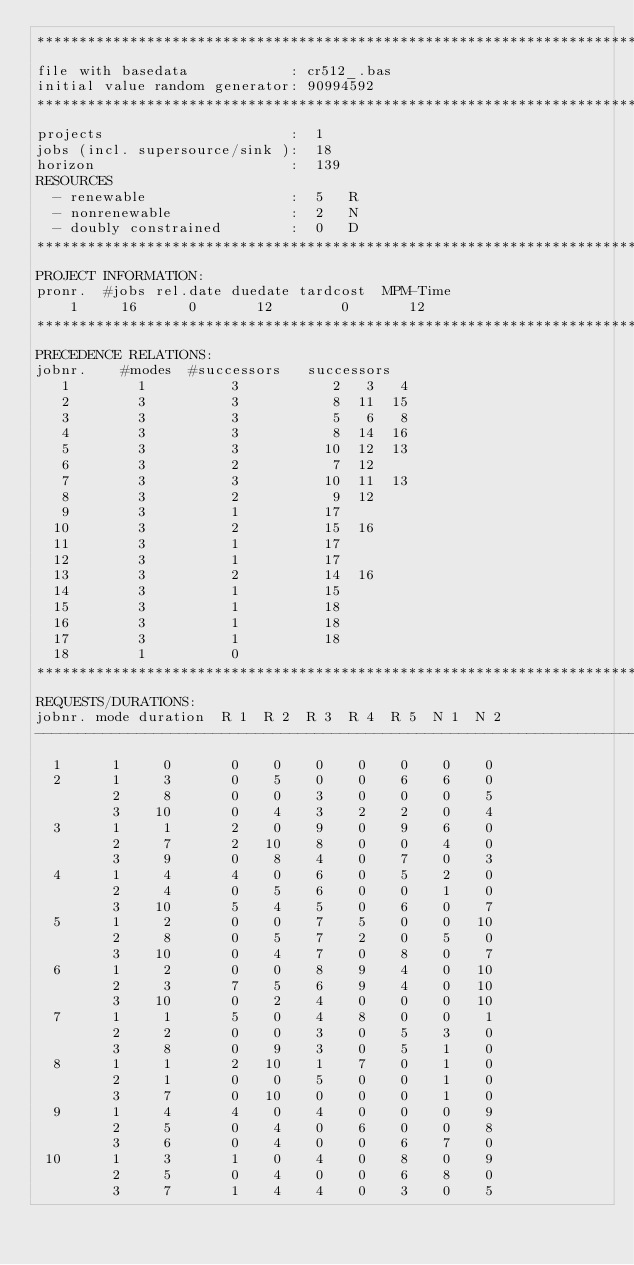Convert code to text. <code><loc_0><loc_0><loc_500><loc_500><_ObjectiveC_>************************************************************************
file with basedata            : cr512_.bas
initial value random generator: 90994592
************************************************************************
projects                      :  1
jobs (incl. supersource/sink ):  18
horizon                       :  139
RESOURCES
  - renewable                 :  5   R
  - nonrenewable              :  2   N
  - doubly constrained        :  0   D
************************************************************************
PROJECT INFORMATION:
pronr.  #jobs rel.date duedate tardcost  MPM-Time
    1     16      0       12        0       12
************************************************************************
PRECEDENCE RELATIONS:
jobnr.    #modes  #successors   successors
   1        1          3           2   3   4
   2        3          3           8  11  15
   3        3          3           5   6   8
   4        3          3           8  14  16
   5        3          3          10  12  13
   6        3          2           7  12
   7        3          3          10  11  13
   8        3          2           9  12
   9        3          1          17
  10        3          2          15  16
  11        3          1          17
  12        3          1          17
  13        3          2          14  16
  14        3          1          15
  15        3          1          18
  16        3          1          18
  17        3          1          18
  18        1          0        
************************************************************************
REQUESTS/DURATIONS:
jobnr. mode duration  R 1  R 2  R 3  R 4  R 5  N 1  N 2
------------------------------------------------------------------------
  1      1     0       0    0    0    0    0    0    0
  2      1     3       0    5    0    0    6    6    0
         2     8       0    0    3    0    0    0    5
         3    10       0    4    3    2    2    0    4
  3      1     1       2    0    9    0    9    6    0
         2     7       2   10    8    0    0    4    0
         3     9       0    8    4    0    7    0    3
  4      1     4       4    0    6    0    5    2    0
         2     4       0    5    6    0    0    1    0
         3    10       5    4    5    0    6    0    7
  5      1     2       0    0    7    5    0    0   10
         2     8       0    5    7    2    0    5    0
         3    10       0    4    7    0    8    0    7
  6      1     2       0    0    8    9    4    0   10
         2     3       7    5    6    9    4    0   10
         3    10       0    2    4    0    0    0   10
  7      1     1       5    0    4    8    0    0    1
         2     2       0    0    3    0    5    3    0
         3     8       0    9    3    0    5    1    0
  8      1     1       2   10    1    7    0    1    0
         2     1       0    0    5    0    0    1    0
         3     7       0   10    0    0    0    1    0
  9      1     4       4    0    4    0    0    0    9
         2     5       0    4    0    6    0    0    8
         3     6       0    4    0    0    6    7    0
 10      1     3       1    0    4    0    8    0    9
         2     5       0    4    0    0    6    8    0
         3     7       1    4    4    0    3    0    5</code> 